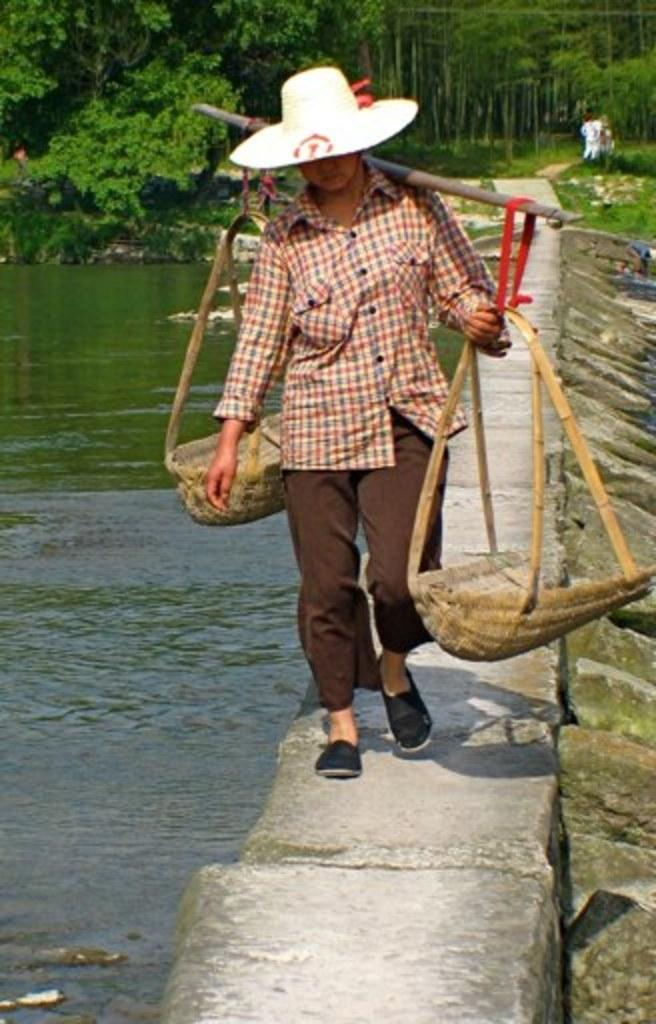Who or what is present in the image? There is a person in the image. What is the person holding in the image? The person is carrying a pole. Where is the person located in the image? The person is on a path. What can be seen in the background of the image? There is water and trees visible in the background of the image. What type of door can be seen in the image? There is no door present in the image. What part of the person's brain can be seen in the image? There is no part of the person's brain visible in the image. 